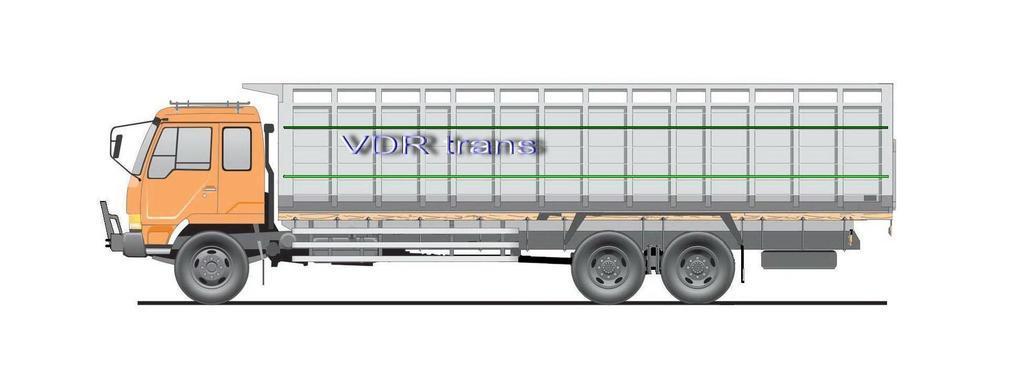Please provide a concise description of this image. This is an animated image. Here we can see a vehicle on the road and there is a text written on the vehicle. 